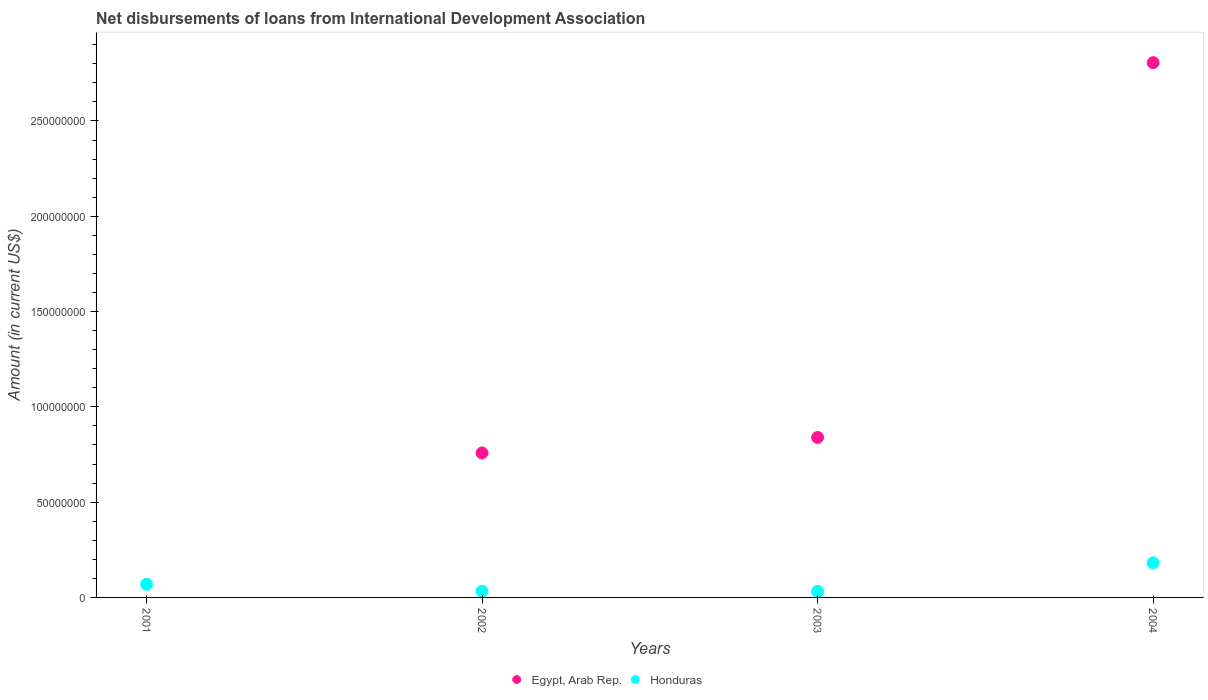How many different coloured dotlines are there?
Provide a succinct answer. 2. Is the number of dotlines equal to the number of legend labels?
Provide a succinct answer. No. What is the amount of loans disbursed in Egypt, Arab Rep. in 2002?
Provide a short and direct response. 7.58e+07. Across all years, what is the maximum amount of loans disbursed in Egypt, Arab Rep.?
Provide a short and direct response. 2.81e+08. Across all years, what is the minimum amount of loans disbursed in Egypt, Arab Rep.?
Provide a succinct answer. 0. What is the total amount of loans disbursed in Egypt, Arab Rep. in the graph?
Provide a short and direct response. 4.40e+08. What is the difference between the amount of loans disbursed in Honduras in 2002 and that in 2003?
Keep it short and to the point. 1.20e+04. What is the difference between the amount of loans disbursed in Egypt, Arab Rep. in 2004 and the amount of loans disbursed in Honduras in 2003?
Provide a short and direct response. 2.77e+08. What is the average amount of loans disbursed in Egypt, Arab Rep. per year?
Offer a terse response. 1.10e+08. In the year 2002, what is the difference between the amount of loans disbursed in Honduras and amount of loans disbursed in Egypt, Arab Rep.?
Keep it short and to the point. -7.26e+07. What is the ratio of the amount of loans disbursed in Egypt, Arab Rep. in 2002 to that in 2004?
Your answer should be very brief. 0.27. Is the amount of loans disbursed in Honduras in 2001 less than that in 2004?
Make the answer very short. Yes. What is the difference between the highest and the second highest amount of loans disbursed in Honduras?
Offer a very short reply. 1.12e+07. What is the difference between the highest and the lowest amount of loans disbursed in Egypt, Arab Rep.?
Make the answer very short. 2.81e+08. Is the sum of the amount of loans disbursed in Honduras in 2002 and 2003 greater than the maximum amount of loans disbursed in Egypt, Arab Rep. across all years?
Keep it short and to the point. No. Does the amount of loans disbursed in Honduras monotonically increase over the years?
Make the answer very short. No. How many dotlines are there?
Offer a terse response. 2. How many years are there in the graph?
Provide a short and direct response. 4. What is the difference between two consecutive major ticks on the Y-axis?
Give a very brief answer. 5.00e+07. Does the graph contain any zero values?
Your response must be concise. Yes. Does the graph contain grids?
Make the answer very short. No. What is the title of the graph?
Offer a terse response. Net disbursements of loans from International Development Association. What is the label or title of the X-axis?
Provide a short and direct response. Years. What is the Amount (in current US$) of Egypt, Arab Rep. in 2001?
Provide a succinct answer. 0. What is the Amount (in current US$) in Honduras in 2001?
Provide a short and direct response. 6.89e+06. What is the Amount (in current US$) in Egypt, Arab Rep. in 2002?
Provide a succinct answer. 7.58e+07. What is the Amount (in current US$) of Honduras in 2002?
Your answer should be very brief. 3.20e+06. What is the Amount (in current US$) of Egypt, Arab Rep. in 2003?
Make the answer very short. 8.39e+07. What is the Amount (in current US$) of Honduras in 2003?
Provide a short and direct response. 3.18e+06. What is the Amount (in current US$) in Egypt, Arab Rep. in 2004?
Provide a succinct answer. 2.81e+08. What is the Amount (in current US$) in Honduras in 2004?
Offer a terse response. 1.81e+07. Across all years, what is the maximum Amount (in current US$) in Egypt, Arab Rep.?
Provide a short and direct response. 2.81e+08. Across all years, what is the maximum Amount (in current US$) of Honduras?
Offer a terse response. 1.81e+07. Across all years, what is the minimum Amount (in current US$) in Honduras?
Your answer should be very brief. 3.18e+06. What is the total Amount (in current US$) in Egypt, Arab Rep. in the graph?
Provide a succinct answer. 4.40e+08. What is the total Amount (in current US$) of Honduras in the graph?
Offer a terse response. 3.14e+07. What is the difference between the Amount (in current US$) in Honduras in 2001 and that in 2002?
Give a very brief answer. 3.69e+06. What is the difference between the Amount (in current US$) in Honduras in 2001 and that in 2003?
Offer a terse response. 3.70e+06. What is the difference between the Amount (in current US$) in Honduras in 2001 and that in 2004?
Offer a terse response. -1.12e+07. What is the difference between the Amount (in current US$) of Egypt, Arab Rep. in 2002 and that in 2003?
Ensure brevity in your answer.  -8.13e+06. What is the difference between the Amount (in current US$) in Honduras in 2002 and that in 2003?
Offer a very short reply. 1.20e+04. What is the difference between the Amount (in current US$) in Egypt, Arab Rep. in 2002 and that in 2004?
Your response must be concise. -2.05e+08. What is the difference between the Amount (in current US$) of Honduras in 2002 and that in 2004?
Your answer should be very brief. -1.49e+07. What is the difference between the Amount (in current US$) of Egypt, Arab Rep. in 2003 and that in 2004?
Provide a short and direct response. -1.97e+08. What is the difference between the Amount (in current US$) in Honduras in 2003 and that in 2004?
Make the answer very short. -1.49e+07. What is the difference between the Amount (in current US$) in Egypt, Arab Rep. in 2002 and the Amount (in current US$) in Honduras in 2003?
Give a very brief answer. 7.26e+07. What is the difference between the Amount (in current US$) in Egypt, Arab Rep. in 2002 and the Amount (in current US$) in Honduras in 2004?
Offer a terse response. 5.77e+07. What is the difference between the Amount (in current US$) in Egypt, Arab Rep. in 2003 and the Amount (in current US$) in Honduras in 2004?
Your answer should be compact. 6.58e+07. What is the average Amount (in current US$) in Egypt, Arab Rep. per year?
Make the answer very short. 1.10e+08. What is the average Amount (in current US$) of Honduras per year?
Your answer should be compact. 7.85e+06. In the year 2002, what is the difference between the Amount (in current US$) of Egypt, Arab Rep. and Amount (in current US$) of Honduras?
Provide a short and direct response. 7.26e+07. In the year 2003, what is the difference between the Amount (in current US$) of Egypt, Arab Rep. and Amount (in current US$) of Honduras?
Offer a terse response. 8.07e+07. In the year 2004, what is the difference between the Amount (in current US$) of Egypt, Arab Rep. and Amount (in current US$) of Honduras?
Ensure brevity in your answer.  2.62e+08. What is the ratio of the Amount (in current US$) of Honduras in 2001 to that in 2002?
Offer a terse response. 2.16. What is the ratio of the Amount (in current US$) in Honduras in 2001 to that in 2003?
Keep it short and to the point. 2.16. What is the ratio of the Amount (in current US$) of Honduras in 2001 to that in 2004?
Ensure brevity in your answer.  0.38. What is the ratio of the Amount (in current US$) in Egypt, Arab Rep. in 2002 to that in 2003?
Your answer should be compact. 0.9. What is the ratio of the Amount (in current US$) in Egypt, Arab Rep. in 2002 to that in 2004?
Make the answer very short. 0.27. What is the ratio of the Amount (in current US$) in Honduras in 2002 to that in 2004?
Your response must be concise. 0.18. What is the ratio of the Amount (in current US$) of Egypt, Arab Rep. in 2003 to that in 2004?
Provide a short and direct response. 0.3. What is the ratio of the Amount (in current US$) in Honduras in 2003 to that in 2004?
Ensure brevity in your answer.  0.18. What is the difference between the highest and the second highest Amount (in current US$) of Egypt, Arab Rep.?
Offer a very short reply. 1.97e+08. What is the difference between the highest and the second highest Amount (in current US$) of Honduras?
Offer a very short reply. 1.12e+07. What is the difference between the highest and the lowest Amount (in current US$) of Egypt, Arab Rep.?
Provide a succinct answer. 2.81e+08. What is the difference between the highest and the lowest Amount (in current US$) of Honduras?
Your answer should be very brief. 1.49e+07. 